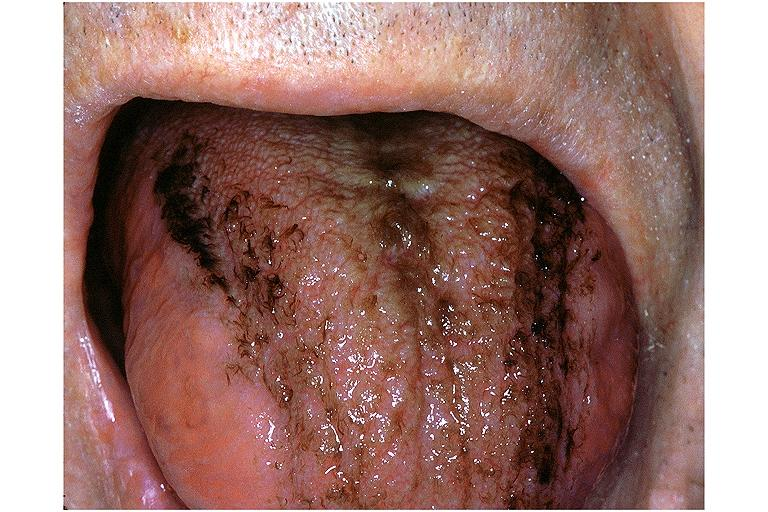does leg show black hairy tongue?
Answer the question using a single word or phrase. No 